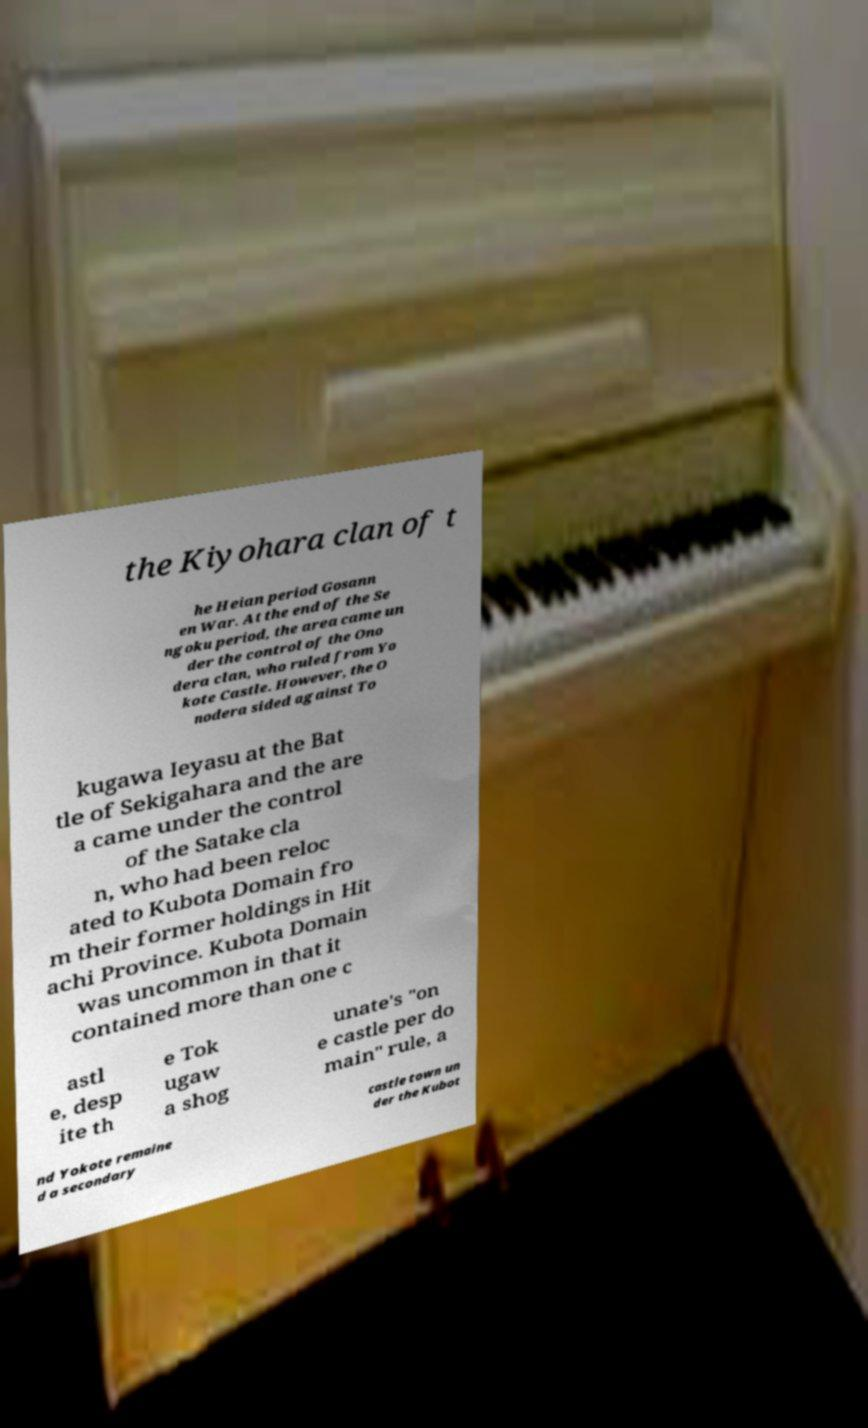There's text embedded in this image that I need extracted. Can you transcribe it verbatim? the Kiyohara clan of t he Heian period Gosann en War. At the end of the Se ngoku period, the area came un der the control of the Ono dera clan, who ruled from Yo kote Castle. However, the O nodera sided against To kugawa Ieyasu at the Bat tle of Sekigahara and the are a came under the control of the Satake cla n, who had been reloc ated to Kubota Domain fro m their former holdings in Hit achi Province. Kubota Domain was uncommon in that it contained more than one c astl e, desp ite th e Tok ugaw a shog unate's "on e castle per do main" rule, a nd Yokote remaine d a secondary castle town un der the Kubot 